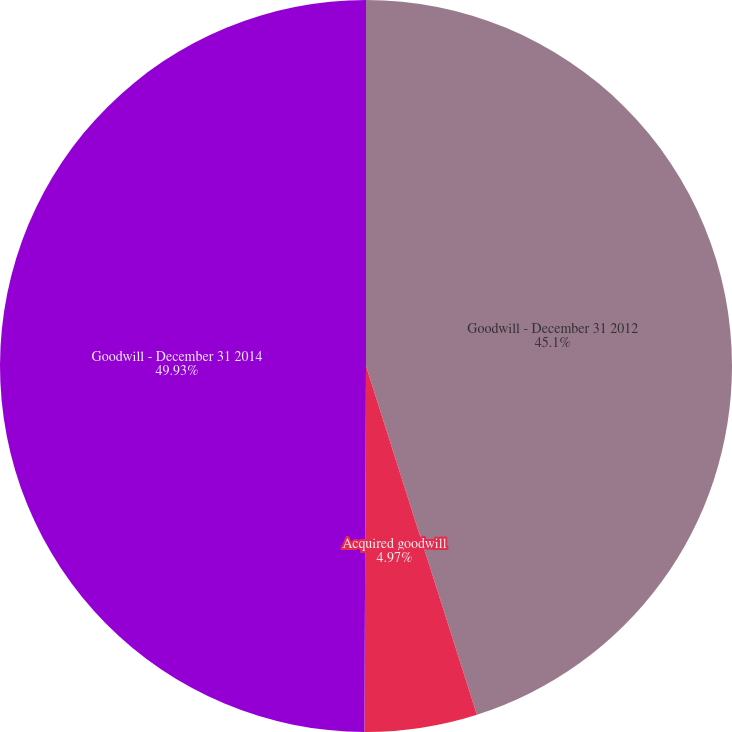Convert chart. <chart><loc_0><loc_0><loc_500><loc_500><pie_chart><fcel>Goodwill - December 31 2012<fcel>Acquired goodwill<fcel>Goodwill - December 31 2014<nl><fcel>45.1%<fcel>4.97%<fcel>49.93%<nl></chart> 